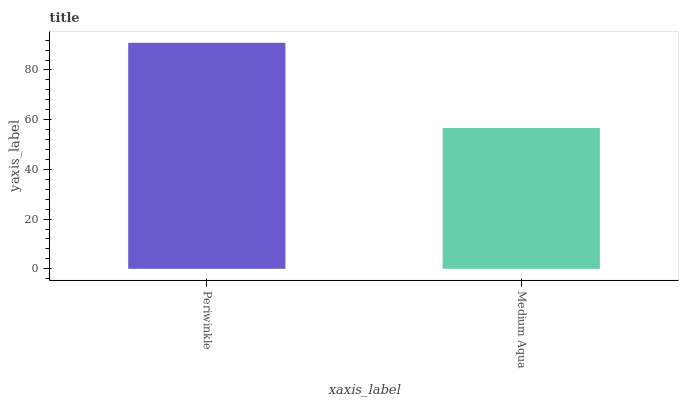Is Medium Aqua the minimum?
Answer yes or no. Yes. Is Periwinkle the maximum?
Answer yes or no. Yes. Is Medium Aqua the maximum?
Answer yes or no. No. Is Periwinkle greater than Medium Aqua?
Answer yes or no. Yes. Is Medium Aqua less than Periwinkle?
Answer yes or no. Yes. Is Medium Aqua greater than Periwinkle?
Answer yes or no. No. Is Periwinkle less than Medium Aqua?
Answer yes or no. No. Is Periwinkle the high median?
Answer yes or no. Yes. Is Medium Aqua the low median?
Answer yes or no. Yes. Is Medium Aqua the high median?
Answer yes or no. No. Is Periwinkle the low median?
Answer yes or no. No. 